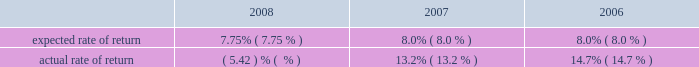Fair valuation the table shows the expected versus actual rate of return on plan assets for the u.s .
Pension and postretirement plans: .
For the foreign plans , pension expense for 2008 was reduced by the expected return of $ 487 million , compared with the actual return of $ ( 883 ) million .
Pension expense for 2007 and 2006 was reduced by expected returns of $ 477 million and $ 384 million , respectively .
Actual returns were higher in 2007 and 2006 than the expected returns in those years .
Discount rate the 2008 and 2007 discount rates for the u.s .
Pension and postretirement plans were selected by reference to a citigroup-specific analysis using each plan 2019s specific cash flows and compared with the moody 2019s aa long-term corporate bond yield for reasonableness .
Citigroup 2019s policy is to round to the nearest tenth of a percent .
Accordingly , at december 31 , 2008 , the discount rate was set at 6.1% ( 6.1 % ) for the pension plans and at 6.0% ( 6.0 % ) for the postretirement welfare plans .
At december 31 , 2007 , the discount rate was set at 6.2% ( 6.2 % ) for the pension plans and 6.0% ( 6.0 % ) for the postretirement plans , referencing a citigroup-specific cash flow analysis .
As of september 30 , 2006 , the u.s .
Pension plan was remeasured to reflect the freeze of benefits accruals for all non-grandfathered participants , effective january 1 , 2008 .
Under the september 30 , 2006 remeasurement and year-end analysis , the resulting plan-specific discount rate for the pension plan was 5.86% ( 5.86 % ) , which was rounded to 5.9% ( 5.9 % ) .
The discount rates for the foreign pension and postretirement plans are selected by reference to high-quality corporate bond rates in countries that have developed corporate bond markets .
However , where developed corporate bond markets do not exist , the discount rates are selected by reference to local government bond rates with a premium added to reflect the additional risk for corporate bonds .
For additional information on the pension and postretirement plans , and on discount rates used in determining pension and postretirement benefit obligations and net benefit expense for the company 2019s plans , as well as the effects of a one percentage-point change in the expected rates of return and the discount rates , see note 9 to the company 2019s consolidated financial statements on page 144 .
Adoption of sfas 158 upon the adoption of sfas no .
158 , employer 2019s accounting for defined benefit pensions and other postretirement benefits ( sfas 158 ) , at december 31 , 2006 , the company recorded an after-tax charge to equity of $ 1.6 billion , which corresponds to the plans 2019 net pension and postretirement liabilities and the write-off of the existing prepaid asset , which relates to unamortized actuarial gains and losses , prior service costs/benefits and transition assets/liabilities .
For a discussion of fair value of assets and liabilities , see 201csignificant accounting policies and significant estimates 201d on page 18 and notes 26 , 27 and 28 to the consolidated financial statements on pages 192 , 202 and 207. .
What was the percentage increase of the expected return from 2007 to 2008? 
Computations: ((487 - 477) / 477)
Answer: 0.02096. 